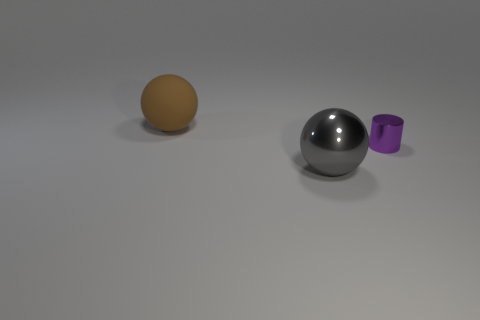Add 1 brown balls. How many objects exist? 4 Subtract all spheres. How many objects are left? 1 Subtract 0 gray cylinders. How many objects are left? 3 Subtract all large rubber spheres. Subtract all rubber objects. How many objects are left? 1 Add 2 large brown spheres. How many large brown spheres are left? 3 Add 1 gray shiny spheres. How many gray shiny spheres exist? 2 